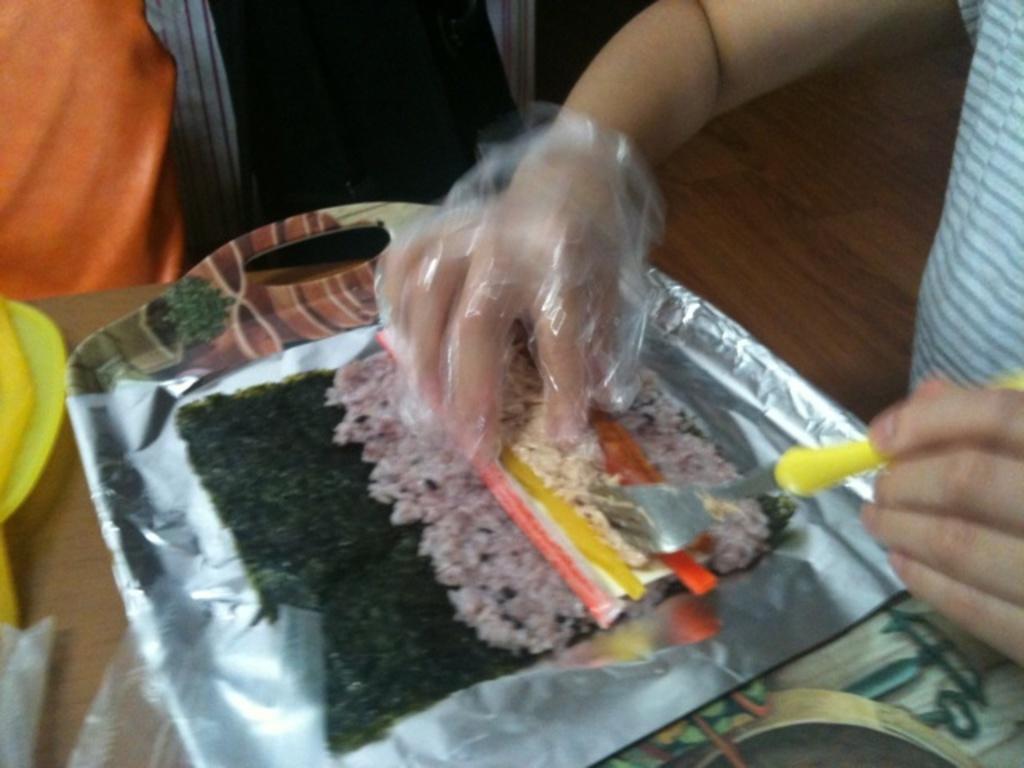Can you describe this image briefly? In this picture there is a person holding a edible with one of his hand and a fork in his another hand and there are some other objects beside it. 